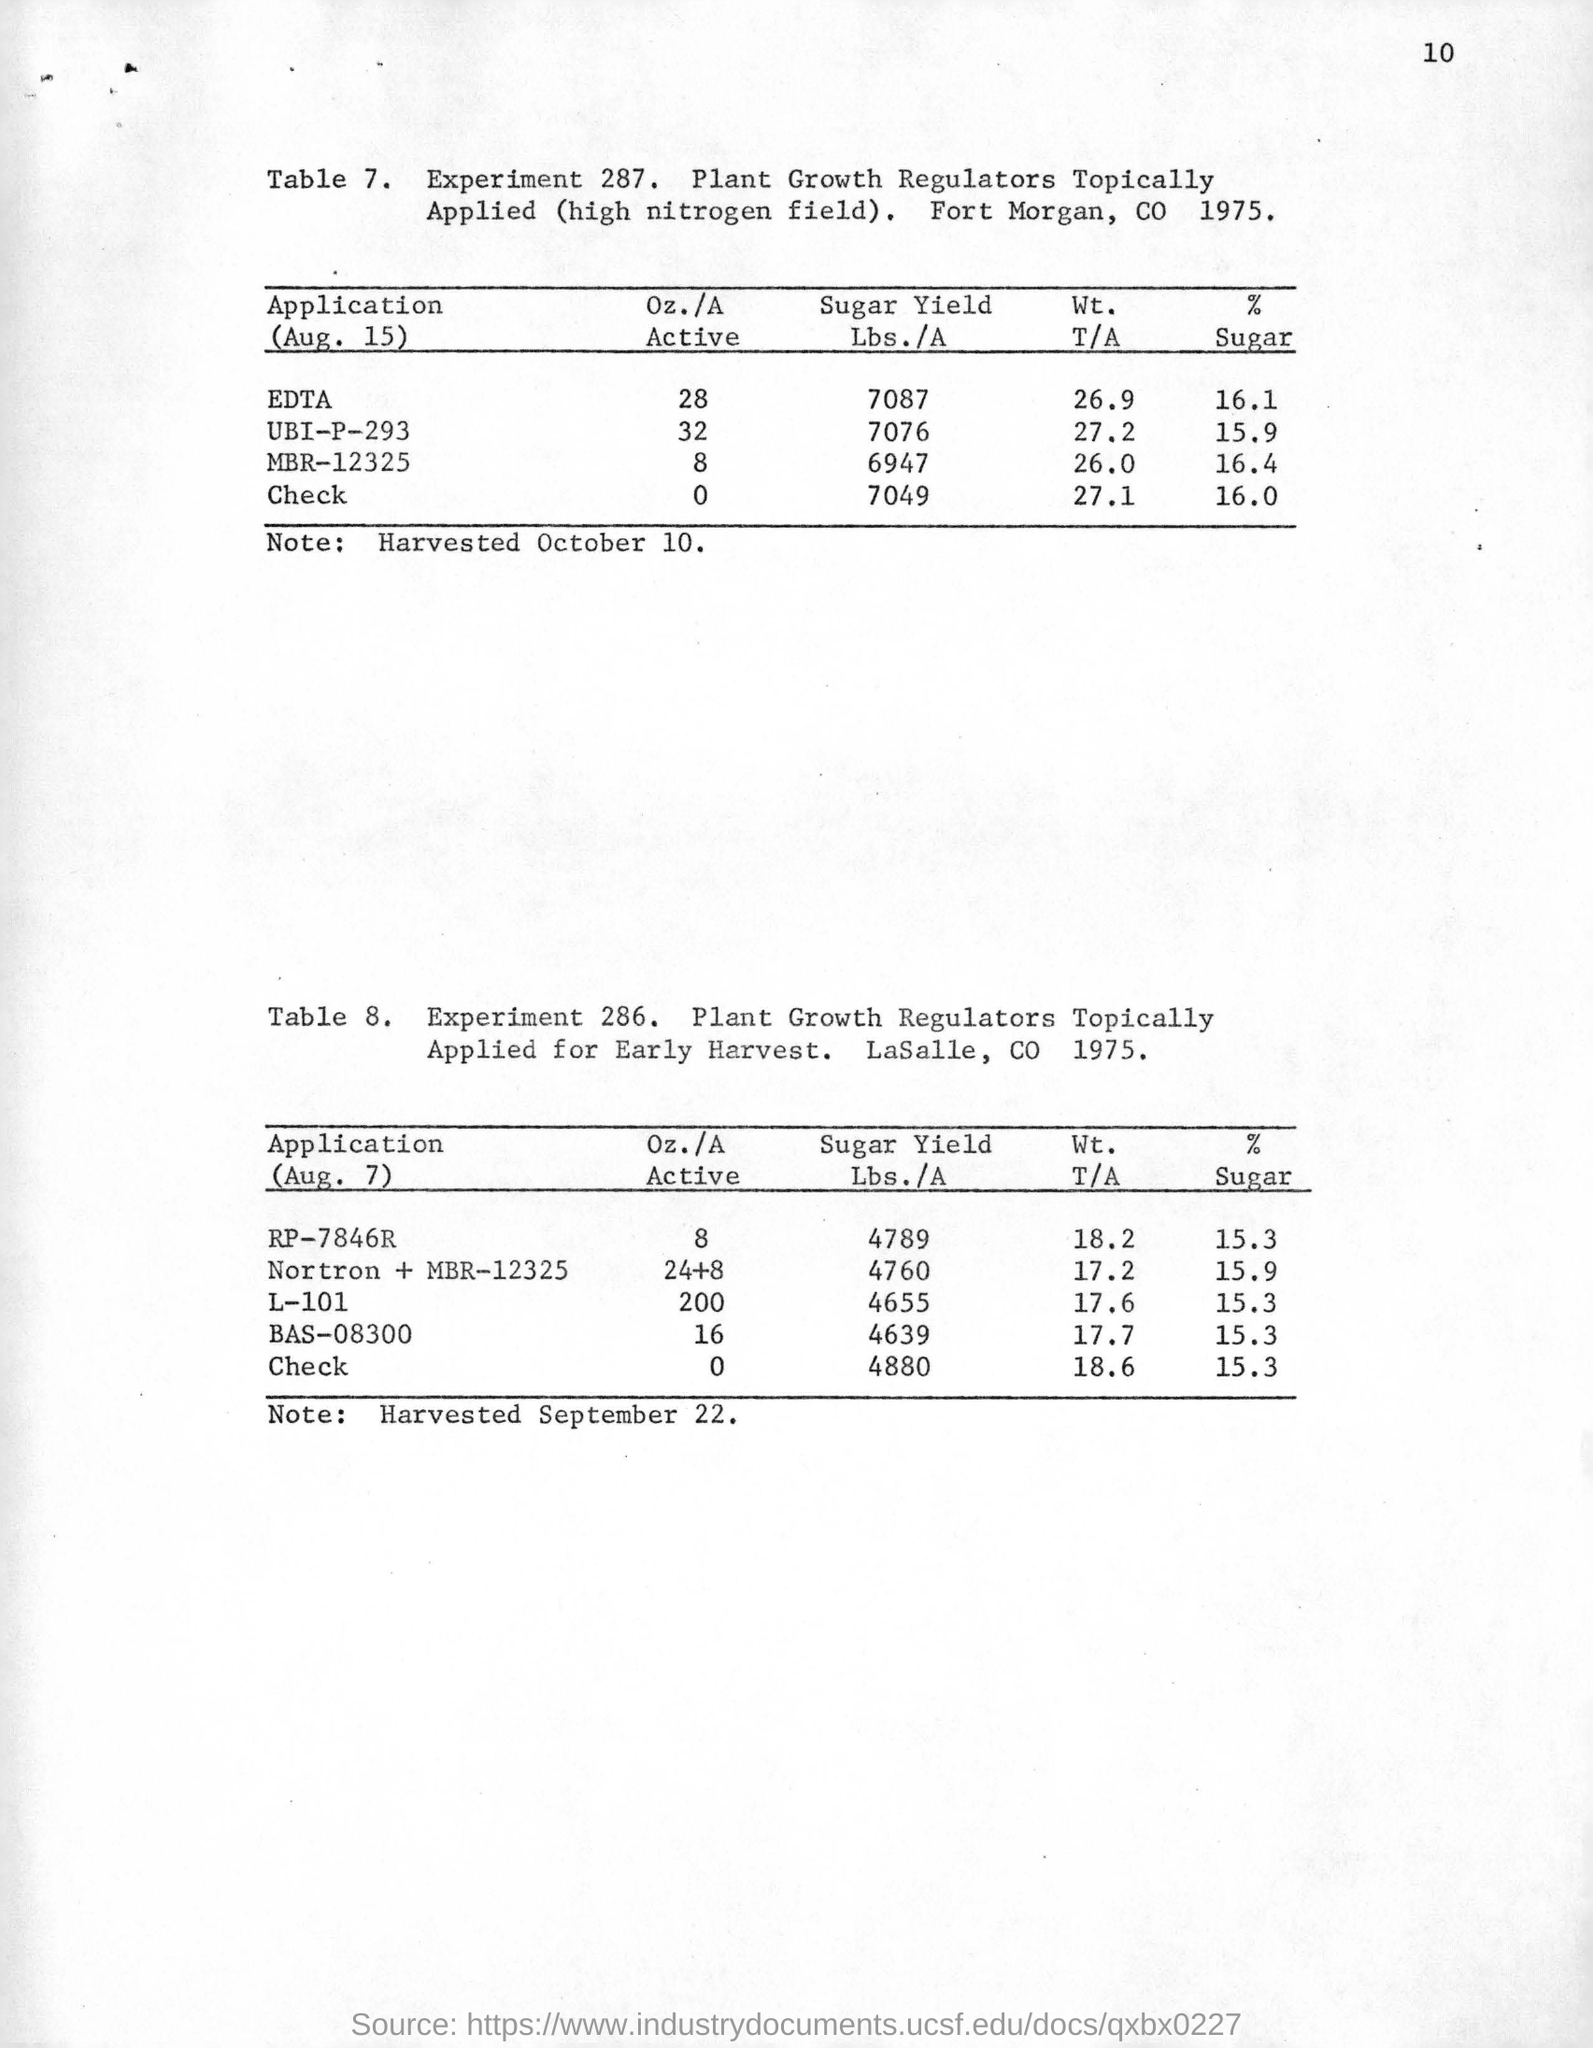Point out several critical features in this image. On August 15, the rate of sugar used in the application of MBR-12325 was 16.4. The results of the experiment, presented in Table 8, tested the effects of plant growth regulators applied topically to plants at an early stage of growth. The experiment was conducted with 286 individual observations. The sugar yield in pounds per acre for the application of EDTA at a rate of 16.1 sugar on August 15 is 7087. 